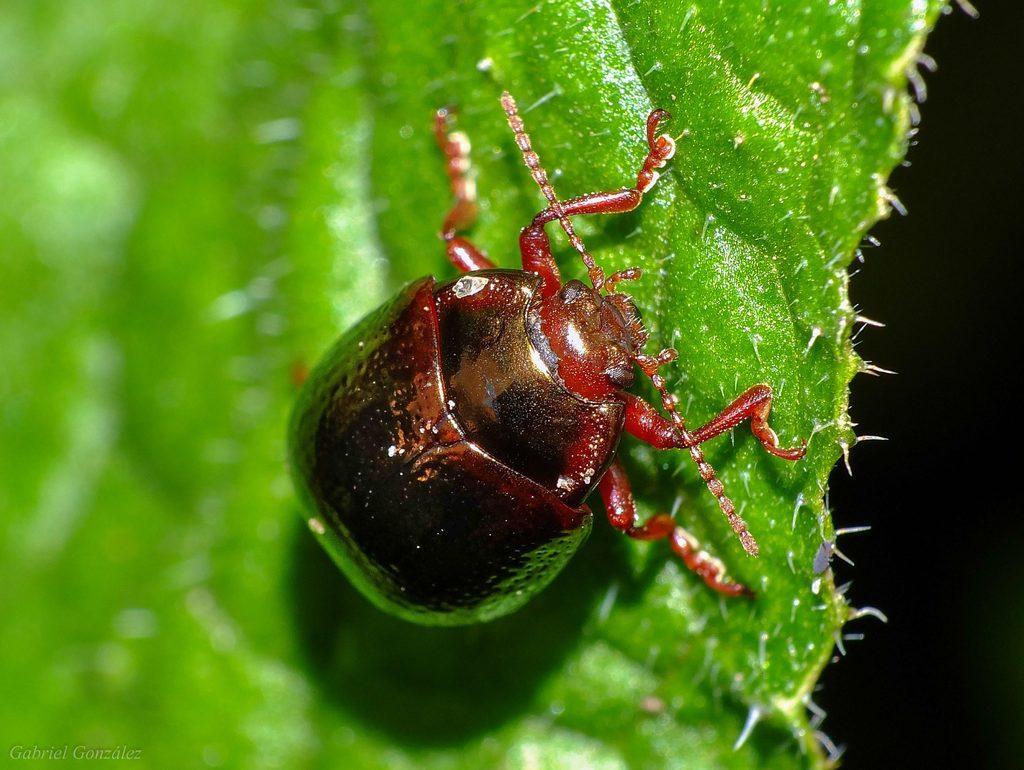Describe this image in one or two sentences. This picture shows a brown color insect on the leaf. We see thorns to the leaf. 